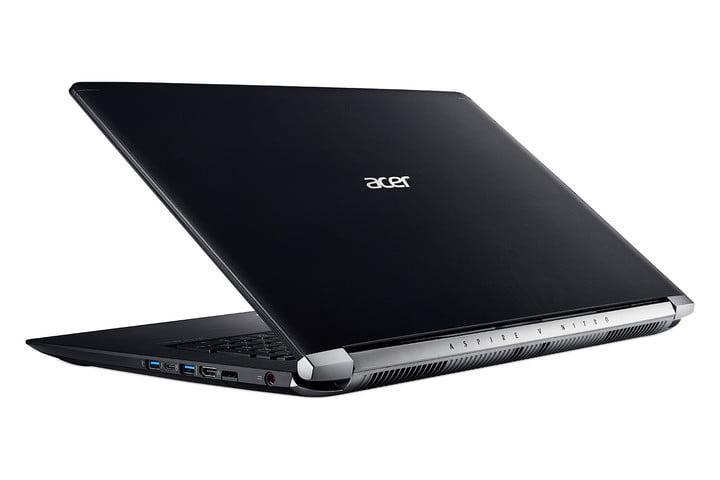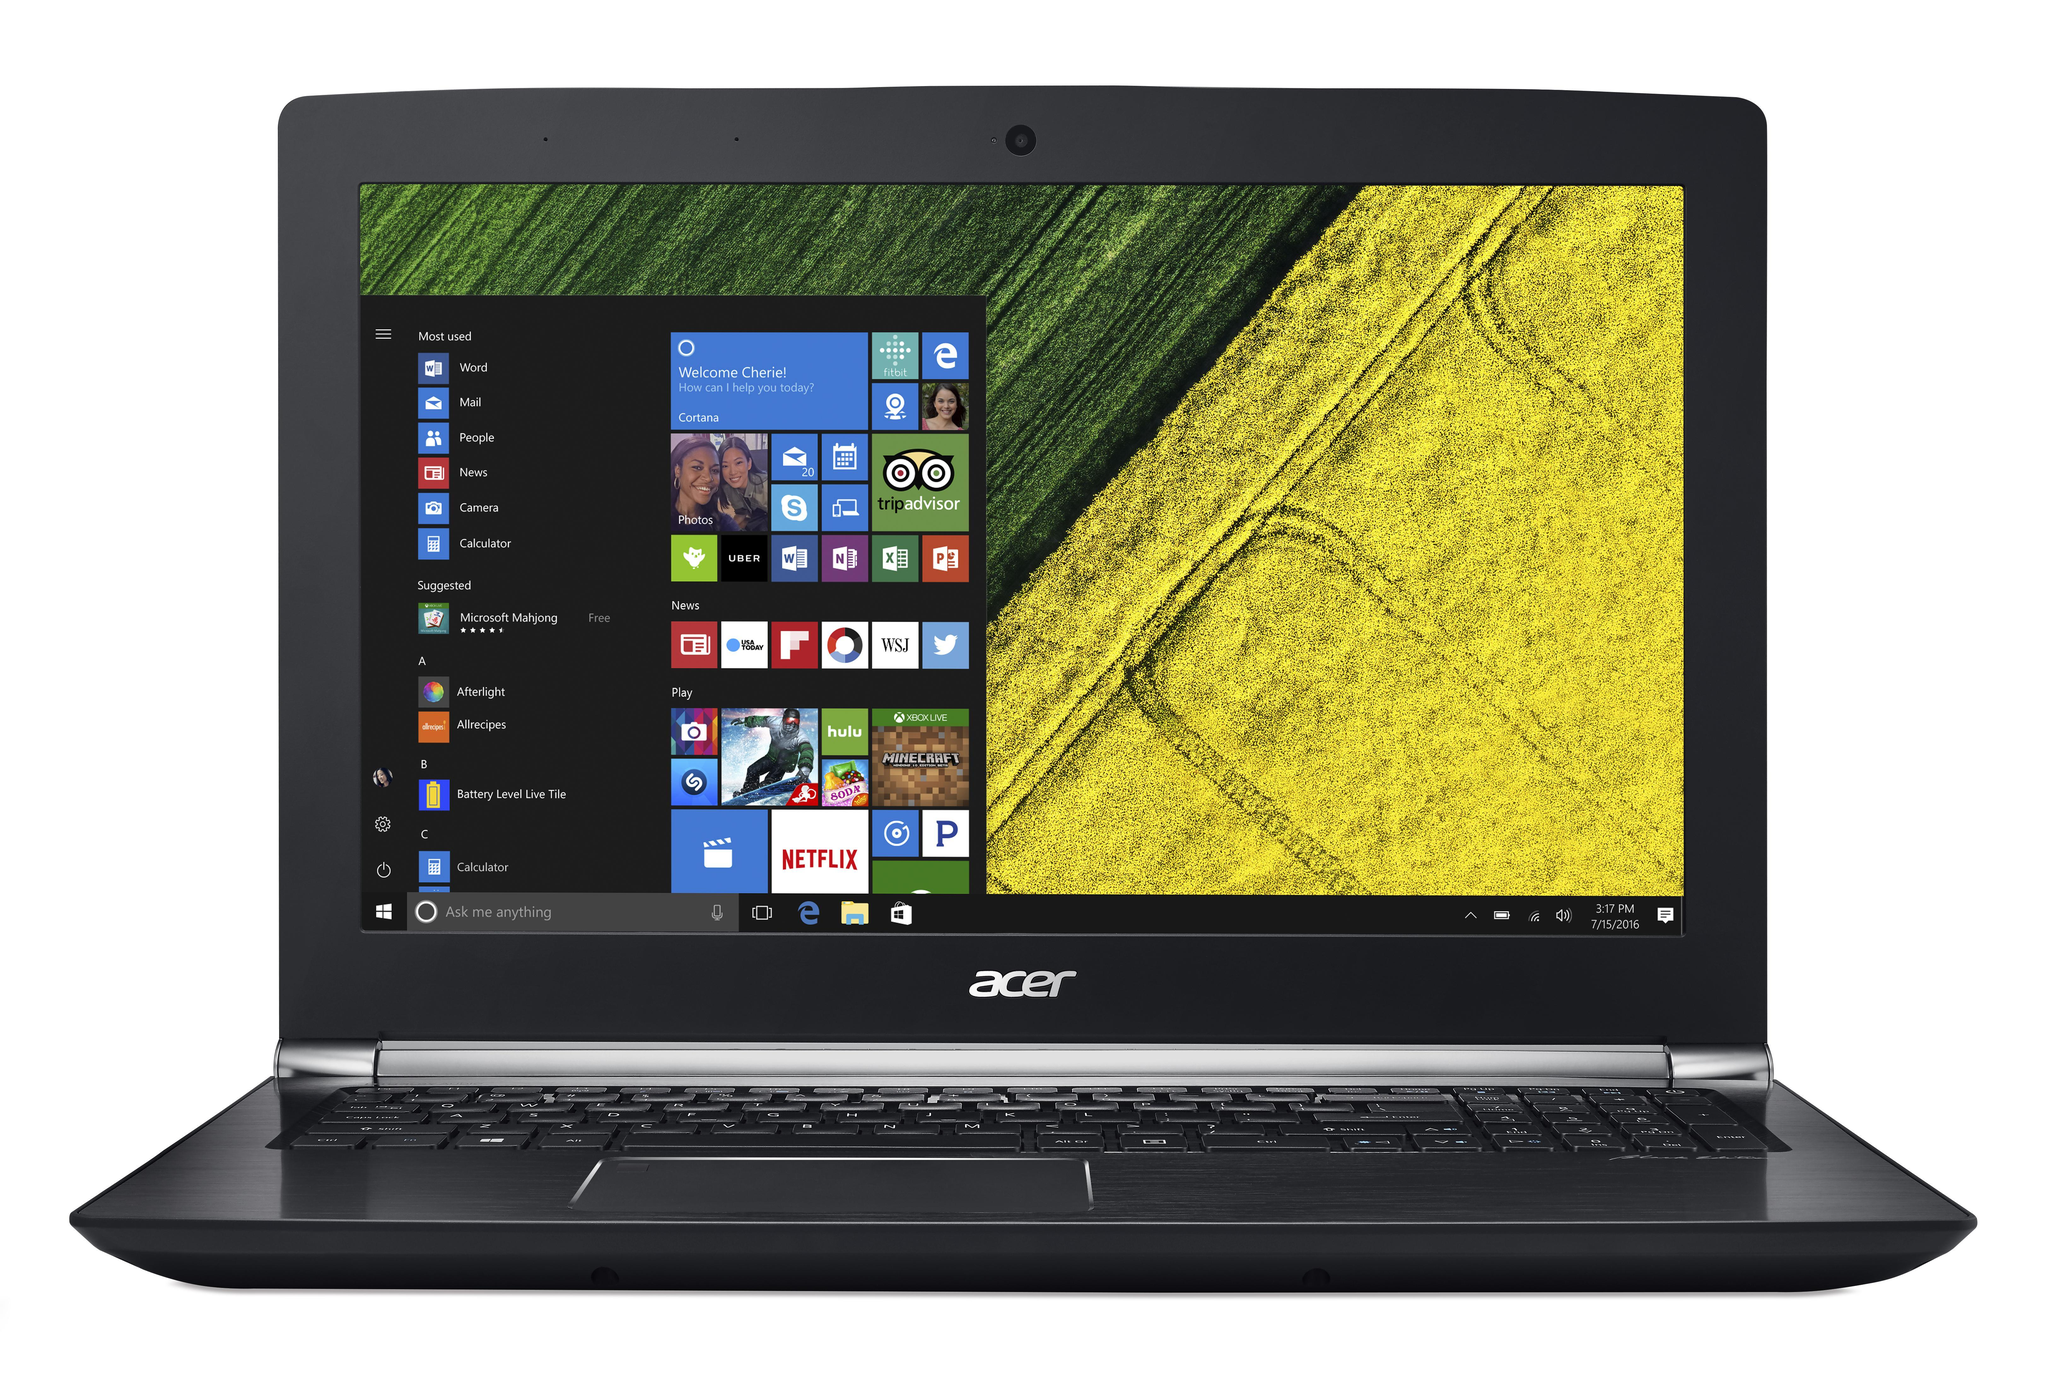The first image is the image on the left, the second image is the image on the right. Assess this claim about the two images: "The right image features a black laptop computer with a green and yellow background visible on its screen". Correct or not? Answer yes or no. Yes. The first image is the image on the left, the second image is the image on the right. For the images shown, is this caption "All laptops are displayed on white backgrounds, and the laptop on the right shows yellow and green sections divided diagonally on the screen." true? Answer yes or no. Yes. 